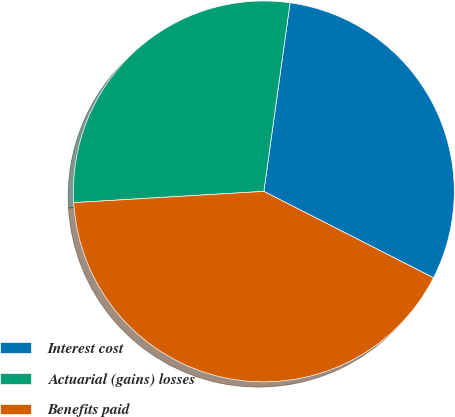<chart> <loc_0><loc_0><loc_500><loc_500><pie_chart><fcel>Interest cost<fcel>Actuarial (gains) losses<fcel>Benefits paid<nl><fcel>30.3%<fcel>28.14%<fcel>41.56%<nl></chart> 